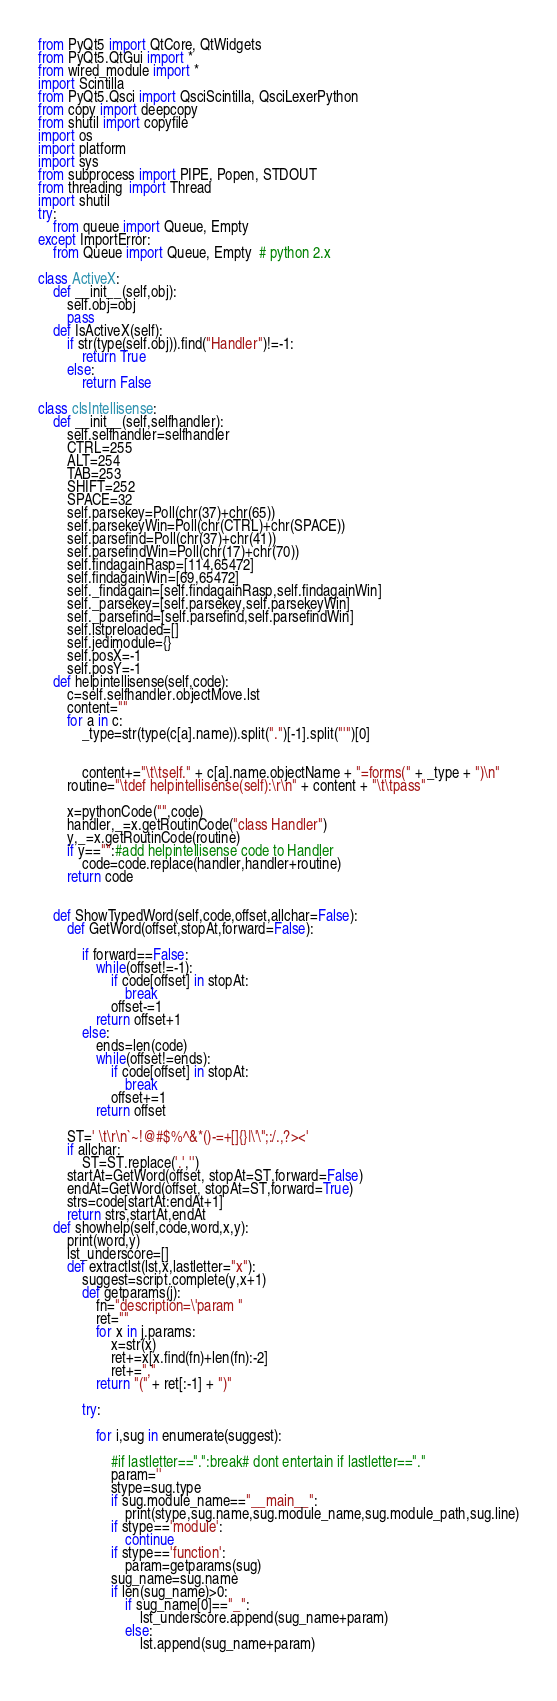<code> <loc_0><loc_0><loc_500><loc_500><_Python_>
from PyQt5 import QtCore, QtWidgets
from PyQt5.QtGui import * 
from wired_module import *    
import Scintilla
from PyQt5.Qsci import QsciScintilla, QsciLexerPython
from copy import deepcopy
from shutil import copyfile
import os
import platform
import sys
from subprocess import PIPE, Popen, STDOUT
from threading  import Thread
import shutil
try:
	from queue import Queue, Empty
except ImportError:
	from Queue import Queue, Empty  # python 2.x

class ActiveX:
	def __init__(self,obj):
		self.obj=obj
		pass
	def IsActiveX(self):
		if str(type(self.obj)).find("Handler")!=-1:
			return True
		else:
			return False

class clsIntellisense:
	def __init__(self,selfhandler):
		self.selfhandler=selfhandler
		CTRL=255
		ALT=254
		TAB=253
		SHIFT=252       
		SPACE=32
		self.parsekey=Poll(chr(37)+chr(65))
		self.parsekeyWin=Poll(chr(CTRL)+chr(SPACE))
		self.parsefind=Poll(chr(37)+chr(41))
		self.parsefindWin=Poll(chr(17)+chr(70))
		self.findagainRasp=[114,65472]
		self.findagainWin=[69,65472]
		self._findagain=[self.findagainRasp,self.findagainWin]
		self._parsekey=[self.parsekey,self.parsekeyWin]
		self._parsefind=[self.parsefind,self.parsefindWin]  
		self.lstpreloaded=[]
		self.jedimodule={}     
		self.posX=-1
		self.posY=-1
	def helpintellisense(self,code):
		c=self.selfhandler.objectMove.lst
		content=""
		for a in c:
			_type=str(type(c[a].name)).split(".")[-1].split("'")[0]


			content+="\t\tself." + c[a].name.objectName + "=forms(" + _type + ")\n"
		routine="\tdef helpintellisense(self):\r\n" + content + "\t\tpass"

		x=pythonCode("",code)
		handler,_=x.getRoutinCode("class Handler") 
		y,_=x.getRoutinCode(routine)
		if y=="":#add helpintellisense code to Handler
			code=code.replace(handler,handler+routine)             
		return code	


	def ShowTypedWord(self,code,offset,allchar=False):
		def GetWord(offset,stopAt,forward=False):

			if forward==False:
				while(offset!=-1):
					if code[offset] in stopAt:
						break
					offset-=1
				return offset+1
			else:
				ends=len(code)
				while(offset!=ends):
					if code[offset] in stopAt:
						break
					offset+=1
				return offset    

		ST=' \t\r\n`~!@#$%^&*()-=+[]{}|\'\";:/.,?><'
		if allchar:
			ST=ST.replace('.','')
		startAt=GetWord(offset, stopAt=ST,forward=False)
		endAt=GetWord(offset, stopAt=ST,forward=True)
		strs=code[startAt:endAt+1]
		return strs,startAt,endAt   		
	def showhelp(self,code,word,x,y):
		print(word,y)
		lst_underscore=[]
		def extractlst(lst,x,lastletter="x"):
			suggest=script.complete(y,x+1)
			def getparams(j):
				fn="description=\'param "
				ret=""
				for x in j.params:
					x=str(x)
					ret+=x[x.find(fn)+len(fn):-2]    
					ret+=","
				return "(" + ret[:-1] + ")"
			
			try:
				
				for i,sug in enumerate(suggest):
					
					#if lastletter==".":break# dont entertain if lastletter=="."
					param=''
					stype=sug.type
					if sug.module_name=="__main__":
						print(stype,sug.name,sug.module_name,sug.module_path,sug.line)
					if stype=='module':
						continue
					if stype=='function':
						param=getparams(sug)
					sug_name=sug.name	
					if len(sug_name)>0:	
						if sug_name[0]=="_":
							lst_underscore.append(sug_name+param)	
						else:	
							lst.append(sug_name+param)				
					</code> 